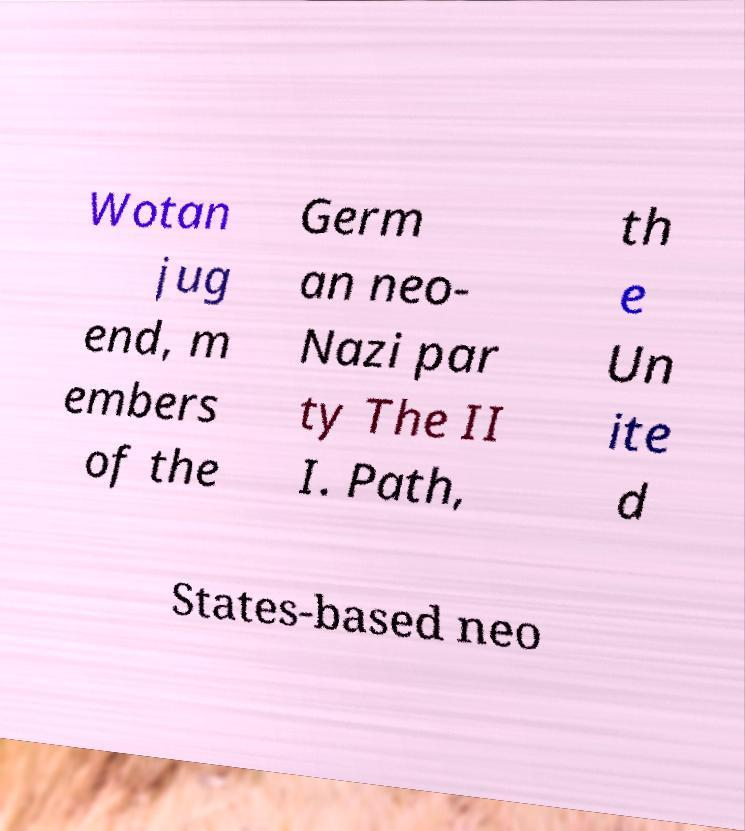Please read and relay the text visible in this image. What does it say? Wotan jug end, m embers of the Germ an neo- Nazi par ty The II I. Path, th e Un ite d States-based neo 